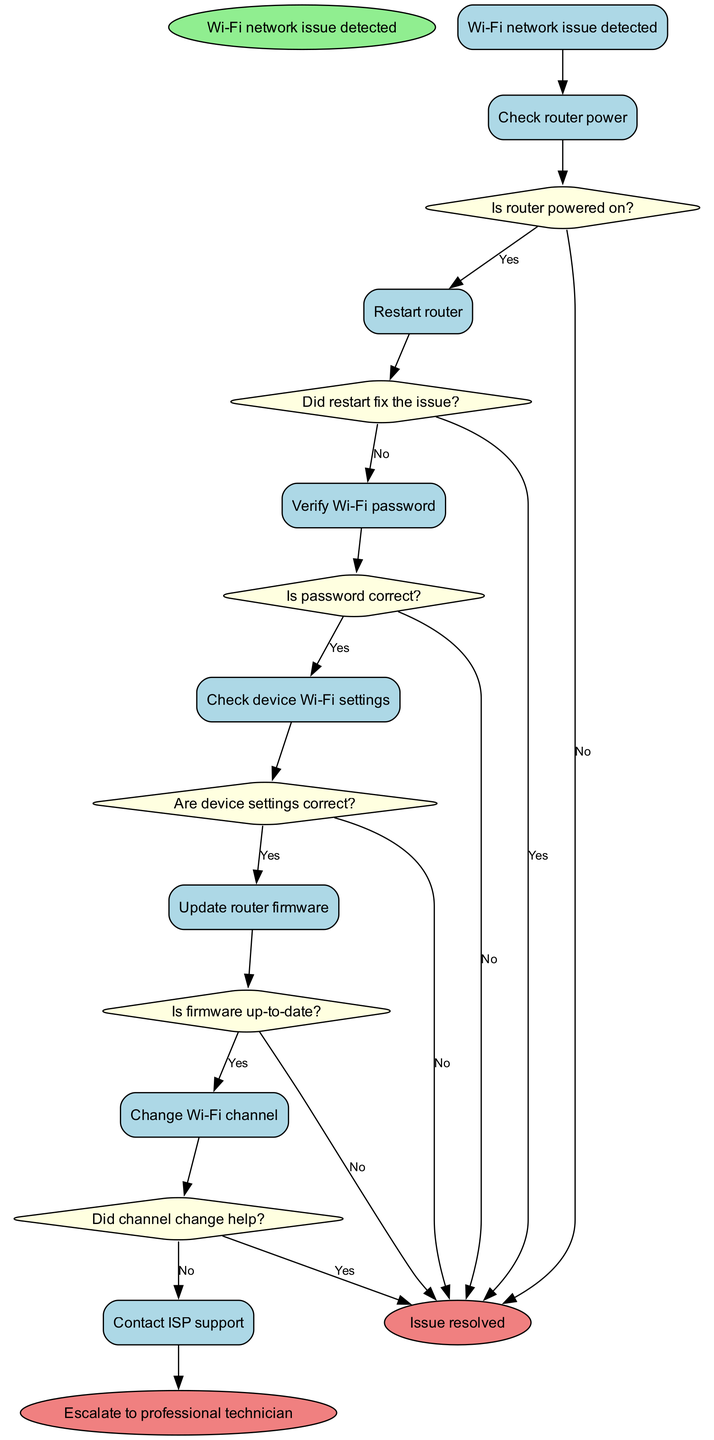What is the starting node of the diagram? The starting node is labeled as "Wi-Fi network issue detected," which indicates the beginning of the troubleshooting process.
Answer: Wi-Fi network issue detected How many activities are listed in the diagram? There are six activities defined in the diagram that represent various steps in the troubleshooting process.
Answer: 6 What does the decision node "Is password correct?" lead to if answered "No"? If the decision "Is password correct?" is answered "No," it leads directly to the end node labeled "Issue resolved," indicating that the incorrect password does not resolve the issue.
Answer: Issue resolved What is the next step after "Restart router" if the restart does not fix the issue? If the restart does not fix the issue, the next step is to verify the Wi-Fi password as indicated by the edges connecting the nodes.
Answer: Verify Wi-Fi password How many end nodes are present in the diagram? There are two end nodes in the diagram indicating the potential final outcomes of the troubleshooting process after all activities have been assessed.
Answer: 2 What happens if the decision “Did channel change help?” is answered "No"? If the answer to "Did channel change help?" is "No," the next action is to contact ISP support, suggesting a need for external assistance in resolving the Wi-Fi issue.
Answer: Contact ISP support What is the final outcome if the Wi-Fi password is correct? If the Wi-Fi password is verified to be correct, the process advances to check the device Wi-Fi settings, which can lead to subsequent actions to resolve the issue.
Answer: Check device Wi-Fi settings Which activity follows after checking device Wi-Fi settings if the settings are not correct? If the device settings are found to be incorrect, the next activity is to update the router firmware according to the flow of the diagram.
Answer: Update router firmware What is the action if "Is firmware up-to-date?" is answered "No"? If the firmware is not up-to-date, it will lead to the end node "Issue resolved," indicating that the outdated firmware does not contribute to the issue resolution.
Answer: Issue resolved 